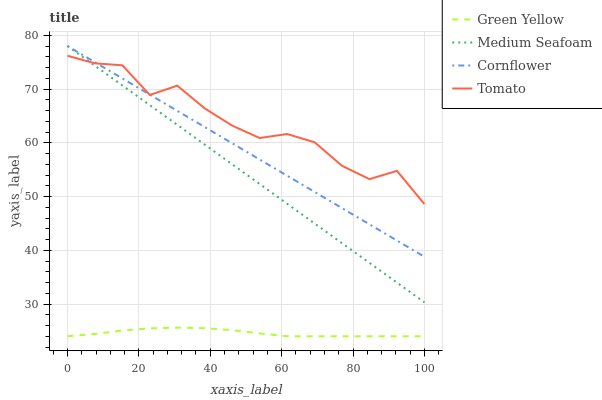Does Green Yellow have the minimum area under the curve?
Answer yes or no. Yes. Does Tomato have the maximum area under the curve?
Answer yes or no. Yes. Does Cornflower have the minimum area under the curve?
Answer yes or no. No. Does Cornflower have the maximum area under the curve?
Answer yes or no. No. Is Cornflower the smoothest?
Answer yes or no. Yes. Is Tomato the roughest?
Answer yes or no. Yes. Is Green Yellow the smoothest?
Answer yes or no. No. Is Green Yellow the roughest?
Answer yes or no. No. Does Cornflower have the lowest value?
Answer yes or no. No. Does Medium Seafoam have the highest value?
Answer yes or no. Yes. Does Green Yellow have the highest value?
Answer yes or no. No. Is Green Yellow less than Tomato?
Answer yes or no. Yes. Is Medium Seafoam greater than Green Yellow?
Answer yes or no. Yes. Does Medium Seafoam intersect Tomato?
Answer yes or no. Yes. Is Medium Seafoam less than Tomato?
Answer yes or no. No. Is Medium Seafoam greater than Tomato?
Answer yes or no. No. Does Green Yellow intersect Tomato?
Answer yes or no. No. 